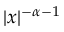Convert formula to latex. <formula><loc_0><loc_0><loc_500><loc_500>| x | ^ { - \alpha - 1 }</formula> 